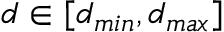<formula> <loc_0><loc_0><loc_500><loc_500>d \in [ d _ { \min } , d _ { \max } ]</formula> 